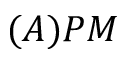Convert formula to latex. <formula><loc_0><loc_0><loc_500><loc_500>( A ) P M</formula> 